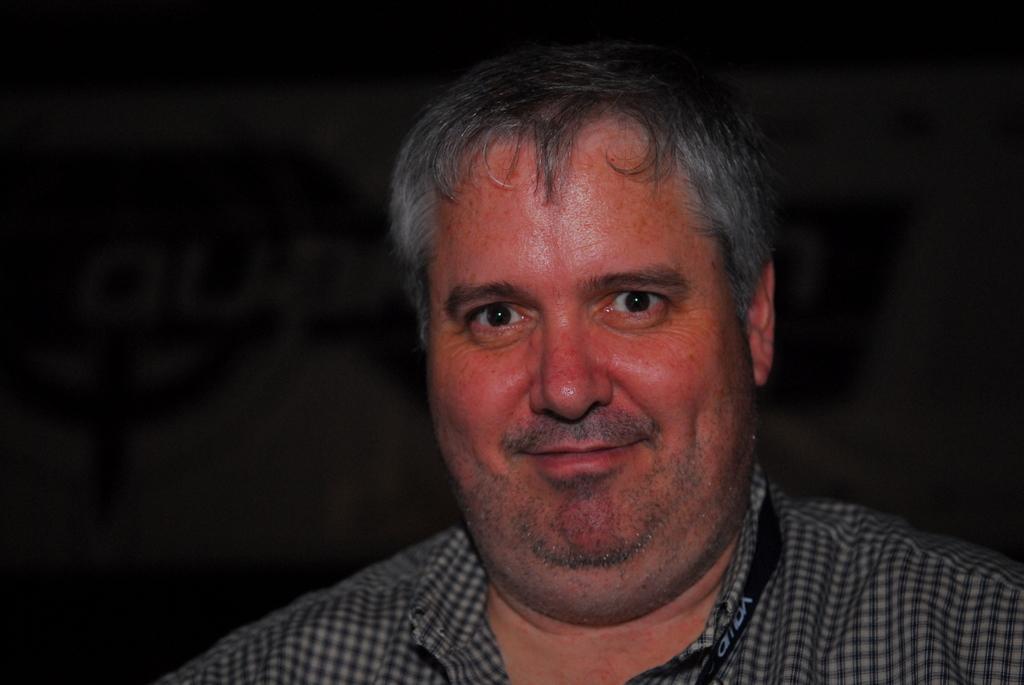How would you summarize this image in a sentence or two? In this image we can see a person's face who is wearing checked shirt and there is black color ID card tag. 